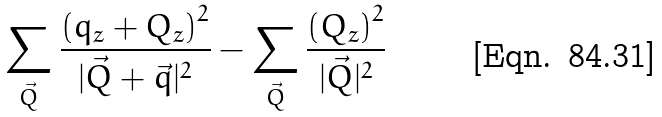<formula> <loc_0><loc_0><loc_500><loc_500>\sum _ { \vec { Q } } \frac { \left ( q _ { z } + Q _ { z } \right ) ^ { 2 } } { | \vec { Q } + \vec { q } | ^ { 2 } } - \sum _ { \vec { Q } } \frac { \left ( Q _ { z } \right ) ^ { 2 } } { | \vec { Q } | ^ { 2 } }</formula> 